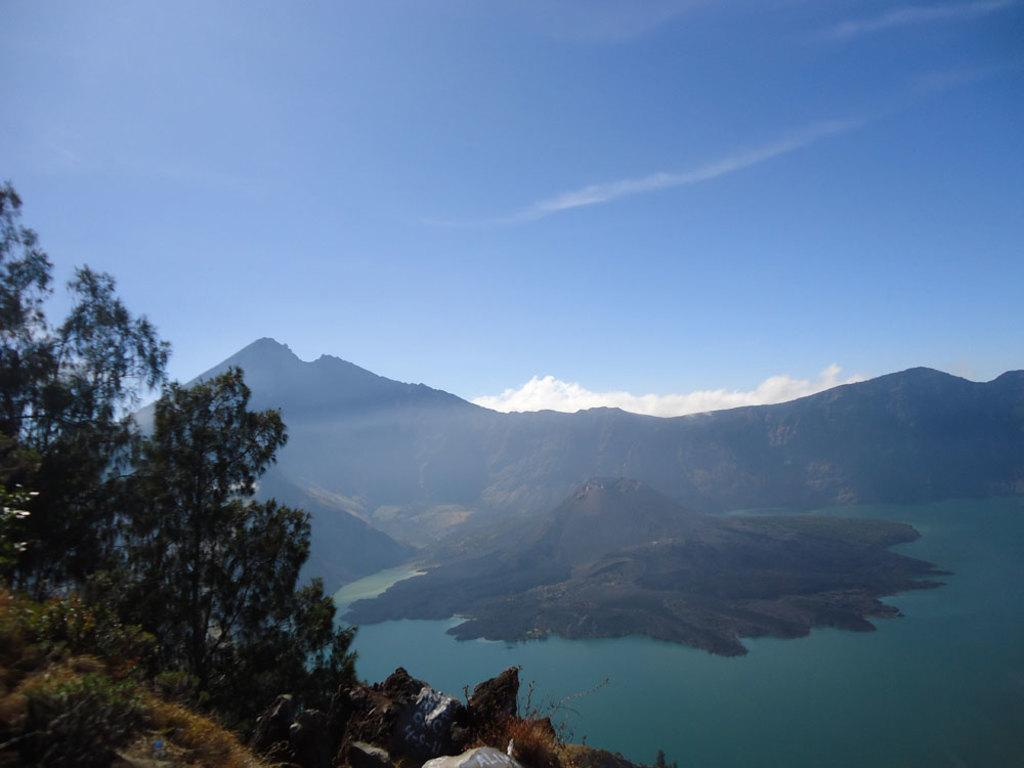What type of vegetation is on the left side of the image? There are trees on the left side of the image. What can be seen in the middle of the image? There is water in the middle of the image. What type of landscape feature is present in the image? There are hills in the image. What is visible at the top of the image? The sky is visible at the top of the image. What hobbies are being practiced by the trees in the image? Trees do not have hobbies, as they are inanimate objects. What reward can be seen being given to the water in the image? There is no reward being given to the water in the image; it is simply a body of water. 